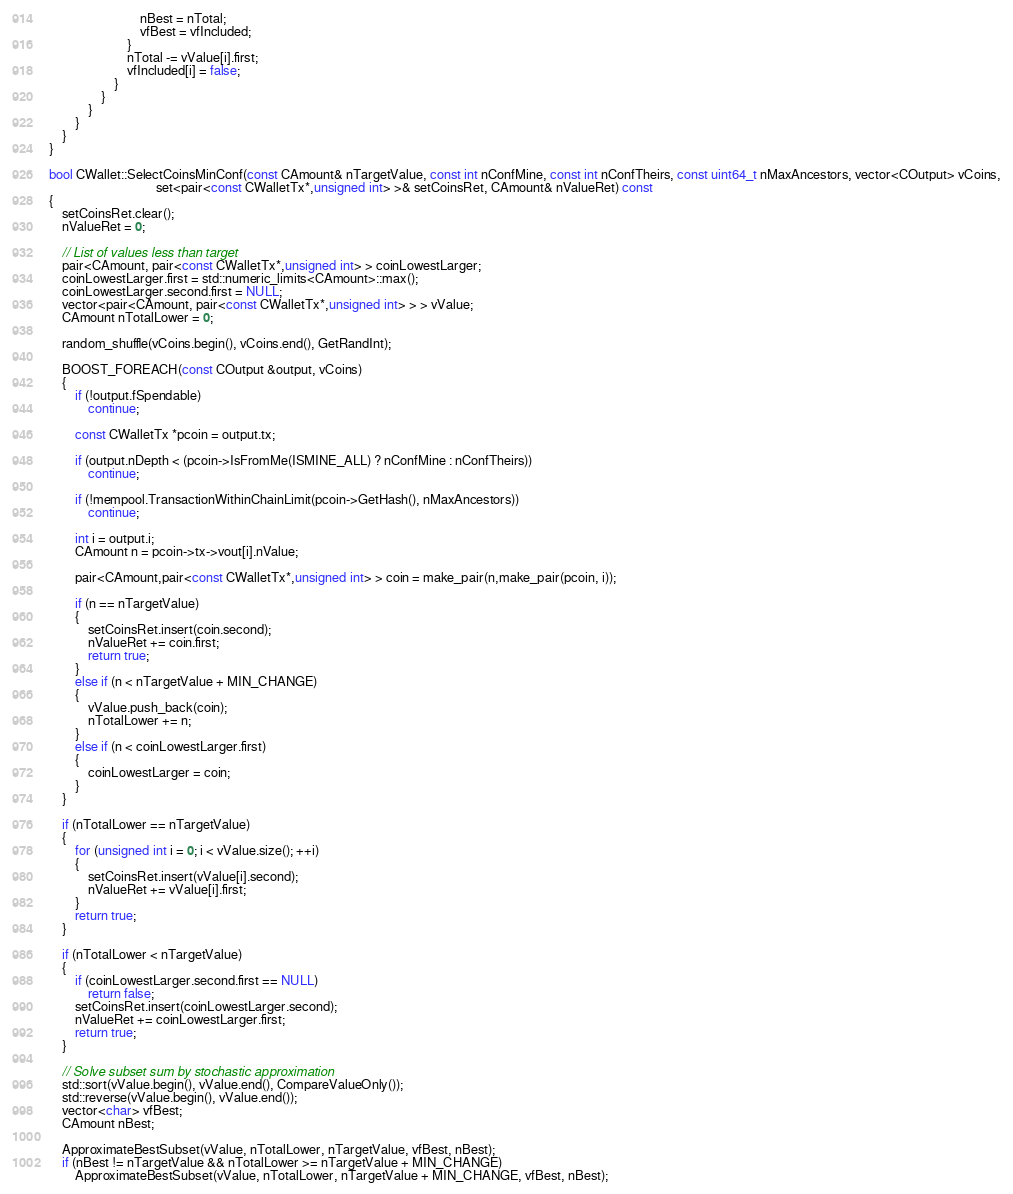Convert code to text. <code><loc_0><loc_0><loc_500><loc_500><_C++_>                            nBest = nTotal;
                            vfBest = vfIncluded;
                        }
                        nTotal -= vValue[i].first;
                        vfIncluded[i] = false;
                    }
                }
            }
        }
    }
}

bool CWallet::SelectCoinsMinConf(const CAmount& nTargetValue, const int nConfMine, const int nConfTheirs, const uint64_t nMaxAncestors, vector<COutput> vCoins,
                                 set<pair<const CWalletTx*,unsigned int> >& setCoinsRet, CAmount& nValueRet) const
{
    setCoinsRet.clear();
    nValueRet = 0;

    // List of values less than target
    pair<CAmount, pair<const CWalletTx*,unsigned int> > coinLowestLarger;
    coinLowestLarger.first = std::numeric_limits<CAmount>::max();
    coinLowestLarger.second.first = NULL;
    vector<pair<CAmount, pair<const CWalletTx*,unsigned int> > > vValue;
    CAmount nTotalLower = 0;

    random_shuffle(vCoins.begin(), vCoins.end(), GetRandInt);

    BOOST_FOREACH(const COutput &output, vCoins)
    {
        if (!output.fSpendable)
            continue;

        const CWalletTx *pcoin = output.tx;

        if (output.nDepth < (pcoin->IsFromMe(ISMINE_ALL) ? nConfMine : nConfTheirs))
            continue;

        if (!mempool.TransactionWithinChainLimit(pcoin->GetHash(), nMaxAncestors))
            continue;

        int i = output.i;
        CAmount n = pcoin->tx->vout[i].nValue;

        pair<CAmount,pair<const CWalletTx*,unsigned int> > coin = make_pair(n,make_pair(pcoin, i));

        if (n == nTargetValue)
        {
            setCoinsRet.insert(coin.second);
            nValueRet += coin.first;
            return true;
        }
        else if (n < nTargetValue + MIN_CHANGE)
        {
            vValue.push_back(coin);
            nTotalLower += n;
        }
        else if (n < coinLowestLarger.first)
        {
            coinLowestLarger = coin;
        }
    }

    if (nTotalLower == nTargetValue)
    {
        for (unsigned int i = 0; i < vValue.size(); ++i)
        {
            setCoinsRet.insert(vValue[i].second);
            nValueRet += vValue[i].first;
        }
        return true;
    }

    if (nTotalLower < nTargetValue)
    {
        if (coinLowestLarger.second.first == NULL)
            return false;
        setCoinsRet.insert(coinLowestLarger.second);
        nValueRet += coinLowestLarger.first;
        return true;
    }

    // Solve subset sum by stochastic approximation
    std::sort(vValue.begin(), vValue.end(), CompareValueOnly());
    std::reverse(vValue.begin(), vValue.end());
    vector<char> vfBest;
    CAmount nBest;

    ApproximateBestSubset(vValue, nTotalLower, nTargetValue, vfBest, nBest);
    if (nBest != nTargetValue && nTotalLower >= nTargetValue + MIN_CHANGE)
        ApproximateBestSubset(vValue, nTotalLower, nTargetValue + MIN_CHANGE, vfBest, nBest);
</code> 